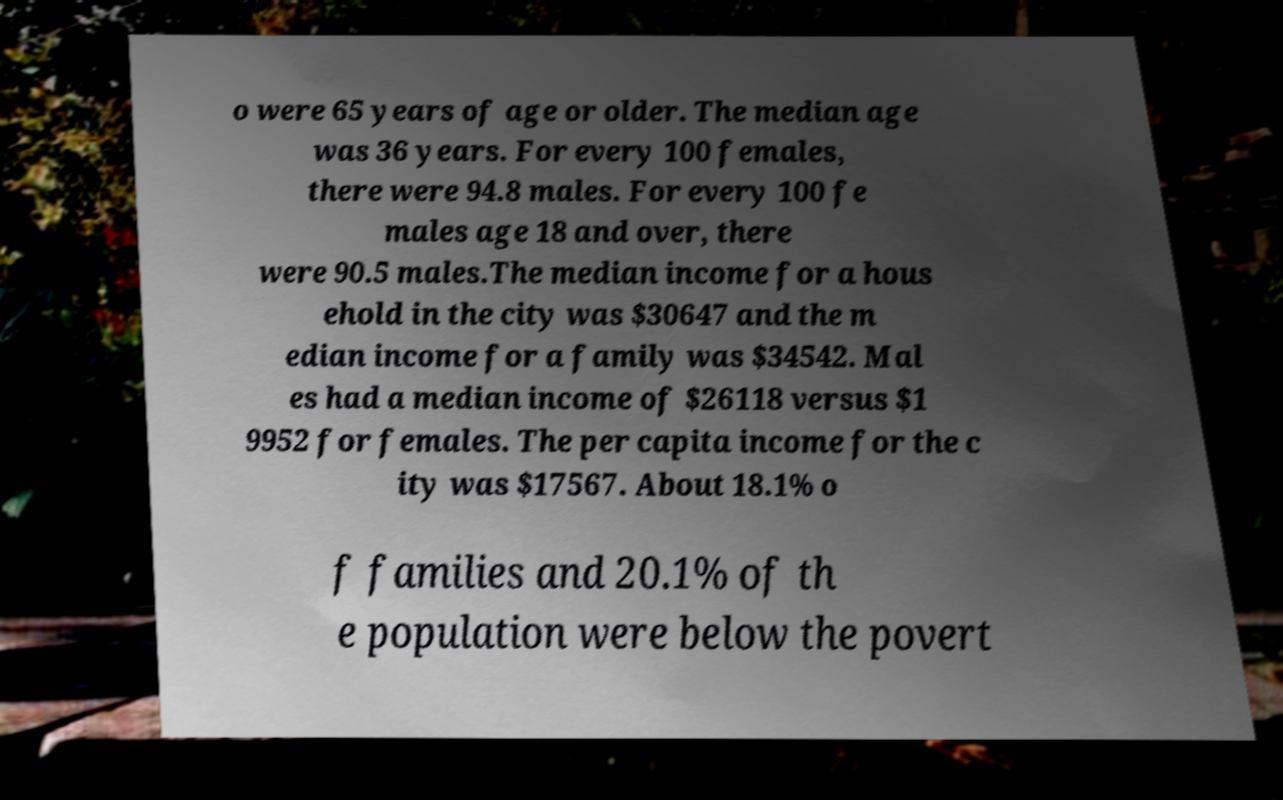Please identify and transcribe the text found in this image. o were 65 years of age or older. The median age was 36 years. For every 100 females, there were 94.8 males. For every 100 fe males age 18 and over, there were 90.5 males.The median income for a hous ehold in the city was $30647 and the m edian income for a family was $34542. Mal es had a median income of $26118 versus $1 9952 for females. The per capita income for the c ity was $17567. About 18.1% o f families and 20.1% of th e population were below the povert 